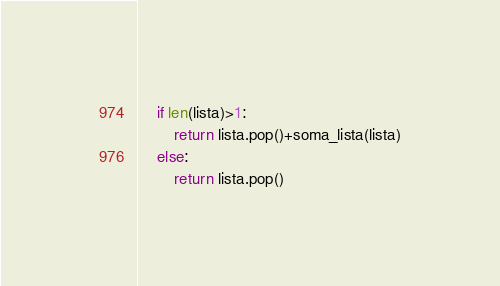<code> <loc_0><loc_0><loc_500><loc_500><_Python_>    if len(lista)>1:
        return lista.pop()+soma_lista(lista)
    else:
        return lista.pop()
</code> 